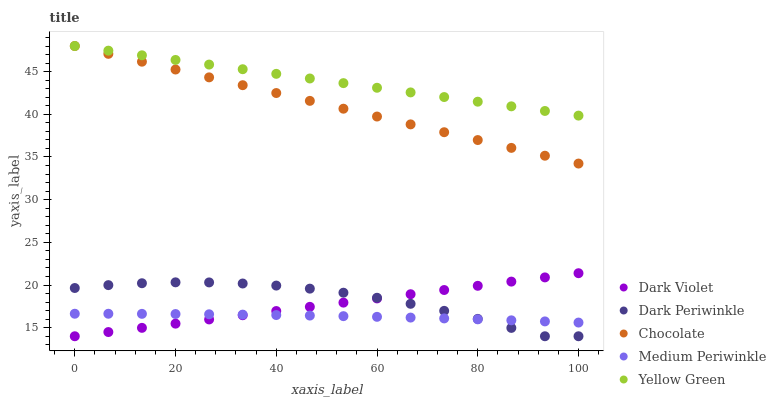Does Medium Periwinkle have the minimum area under the curve?
Answer yes or no. Yes. Does Yellow Green have the maximum area under the curve?
Answer yes or no. Yes. Does Dark Periwinkle have the minimum area under the curve?
Answer yes or no. No. Does Dark Periwinkle have the maximum area under the curve?
Answer yes or no. No. Is Dark Violet the smoothest?
Answer yes or no. Yes. Is Dark Periwinkle the roughest?
Answer yes or no. Yes. Is Medium Periwinkle the smoothest?
Answer yes or no. No. Is Medium Periwinkle the roughest?
Answer yes or no. No. Does Dark Periwinkle have the lowest value?
Answer yes or no. Yes. Does Medium Periwinkle have the lowest value?
Answer yes or no. No. Does Chocolate have the highest value?
Answer yes or no. Yes. Does Dark Periwinkle have the highest value?
Answer yes or no. No. Is Dark Periwinkle less than Chocolate?
Answer yes or no. Yes. Is Chocolate greater than Dark Violet?
Answer yes or no. Yes. Does Dark Violet intersect Dark Periwinkle?
Answer yes or no. Yes. Is Dark Violet less than Dark Periwinkle?
Answer yes or no. No. Is Dark Violet greater than Dark Periwinkle?
Answer yes or no. No. Does Dark Periwinkle intersect Chocolate?
Answer yes or no. No. 